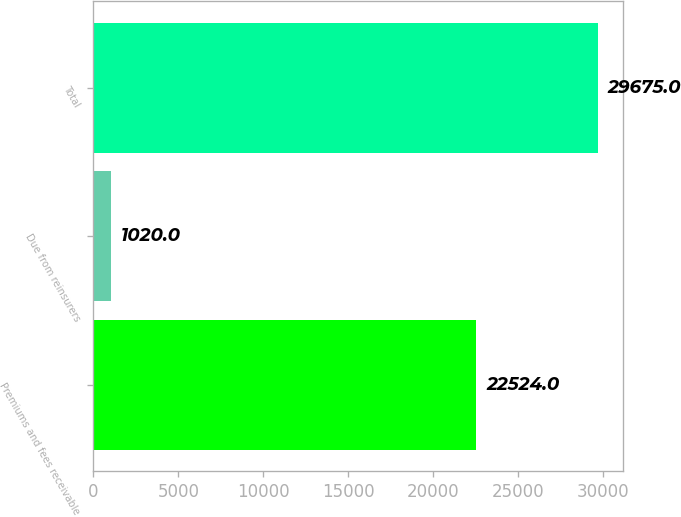Convert chart to OTSL. <chart><loc_0><loc_0><loc_500><loc_500><bar_chart><fcel>Premiums and fees receivable<fcel>Due from reinsurers<fcel>Total<nl><fcel>22524<fcel>1020<fcel>29675<nl></chart> 